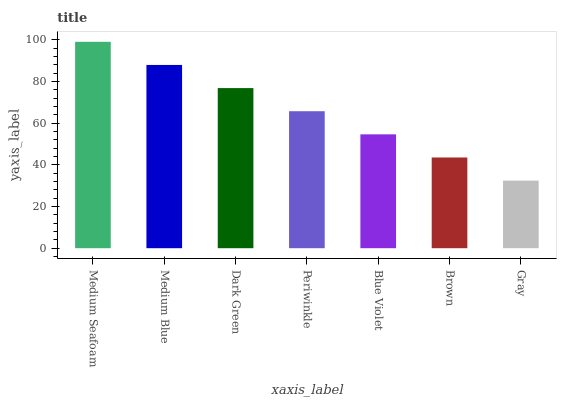Is Gray the minimum?
Answer yes or no. Yes. Is Medium Seafoam the maximum?
Answer yes or no. Yes. Is Medium Blue the minimum?
Answer yes or no. No. Is Medium Blue the maximum?
Answer yes or no. No. Is Medium Seafoam greater than Medium Blue?
Answer yes or no. Yes. Is Medium Blue less than Medium Seafoam?
Answer yes or no. Yes. Is Medium Blue greater than Medium Seafoam?
Answer yes or no. No. Is Medium Seafoam less than Medium Blue?
Answer yes or no. No. Is Periwinkle the high median?
Answer yes or no. Yes. Is Periwinkle the low median?
Answer yes or no. Yes. Is Medium Blue the high median?
Answer yes or no. No. Is Gray the low median?
Answer yes or no. No. 